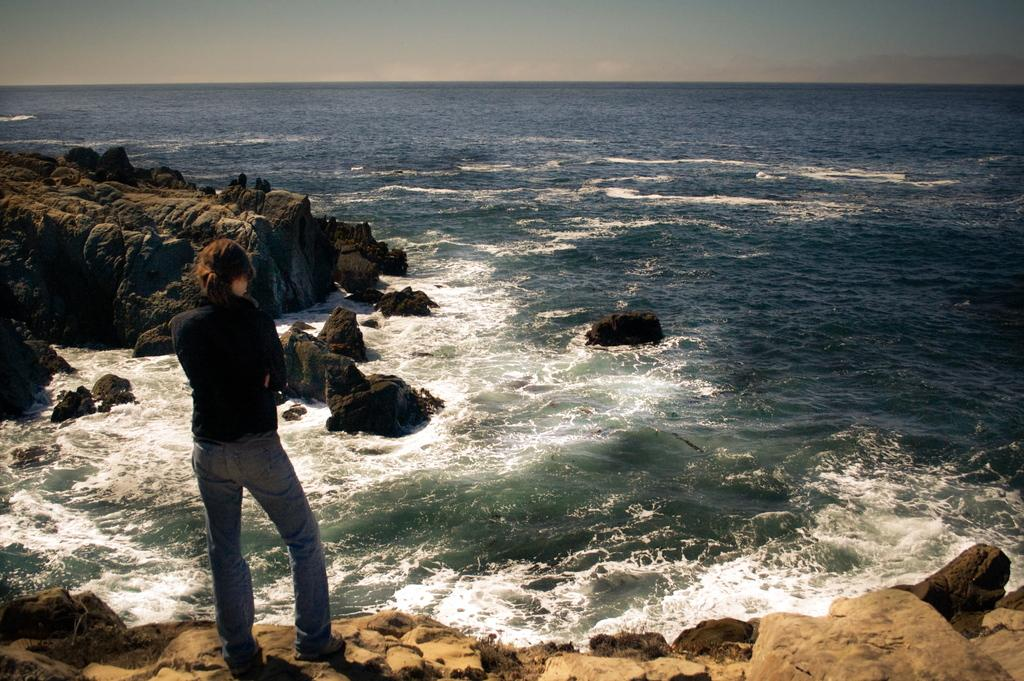Who is standing on the left side of the image? There is a lady standing on the left side of the image. What is in front of the lady? There is a sea in front of the lady. What other objects or features can be seen in the image? There are rocks visible in the image. What can be seen above the sea and rocks? The sky is visible in the image. What does the root of the tree smell like in the image? There is no tree or root present in the image, so it is not possible to determine the smell. 